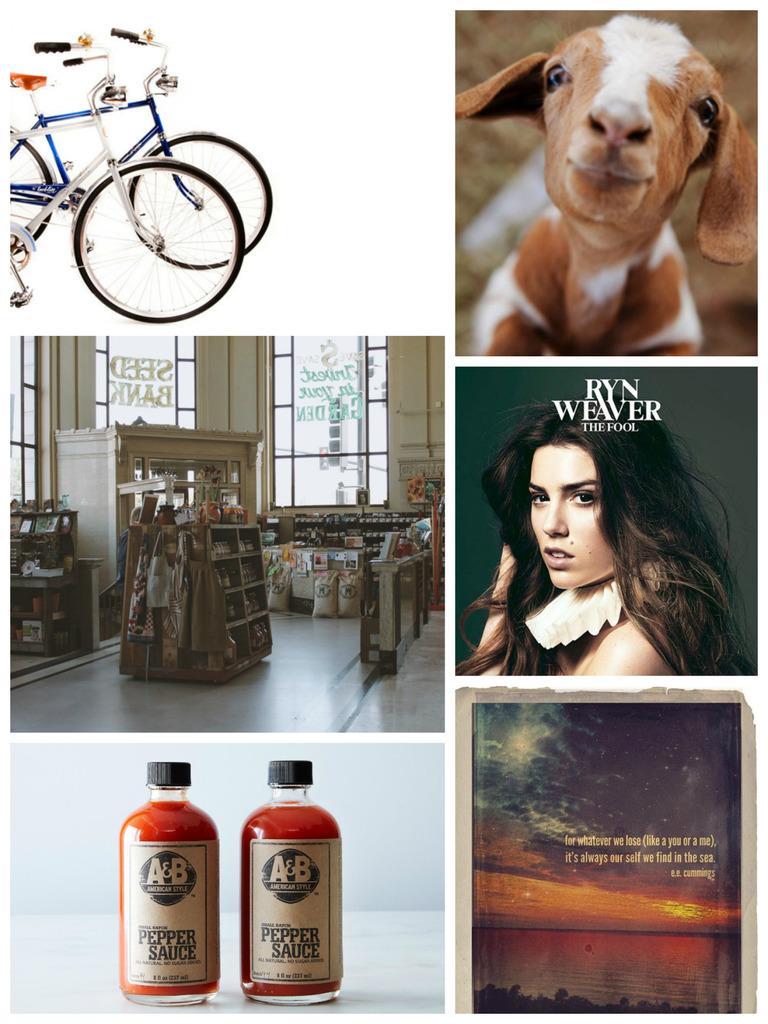In one or two sentences, can you explain what this image depicts? This is a collage picture, there are two bicycles in one picture and a goat in other picture and there are shelves on a floor and behind the shelf there are glass window. There are two glass bottles on a table and a paper. 